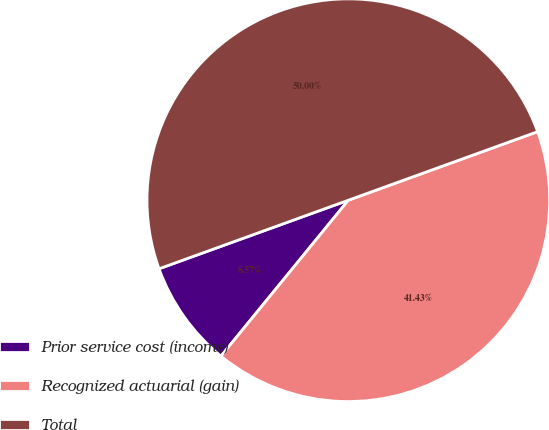<chart> <loc_0><loc_0><loc_500><loc_500><pie_chart><fcel>Prior service cost (income)<fcel>Recognized actuarial (gain)<fcel>Total<nl><fcel>8.57%<fcel>41.43%<fcel>50.0%<nl></chart> 